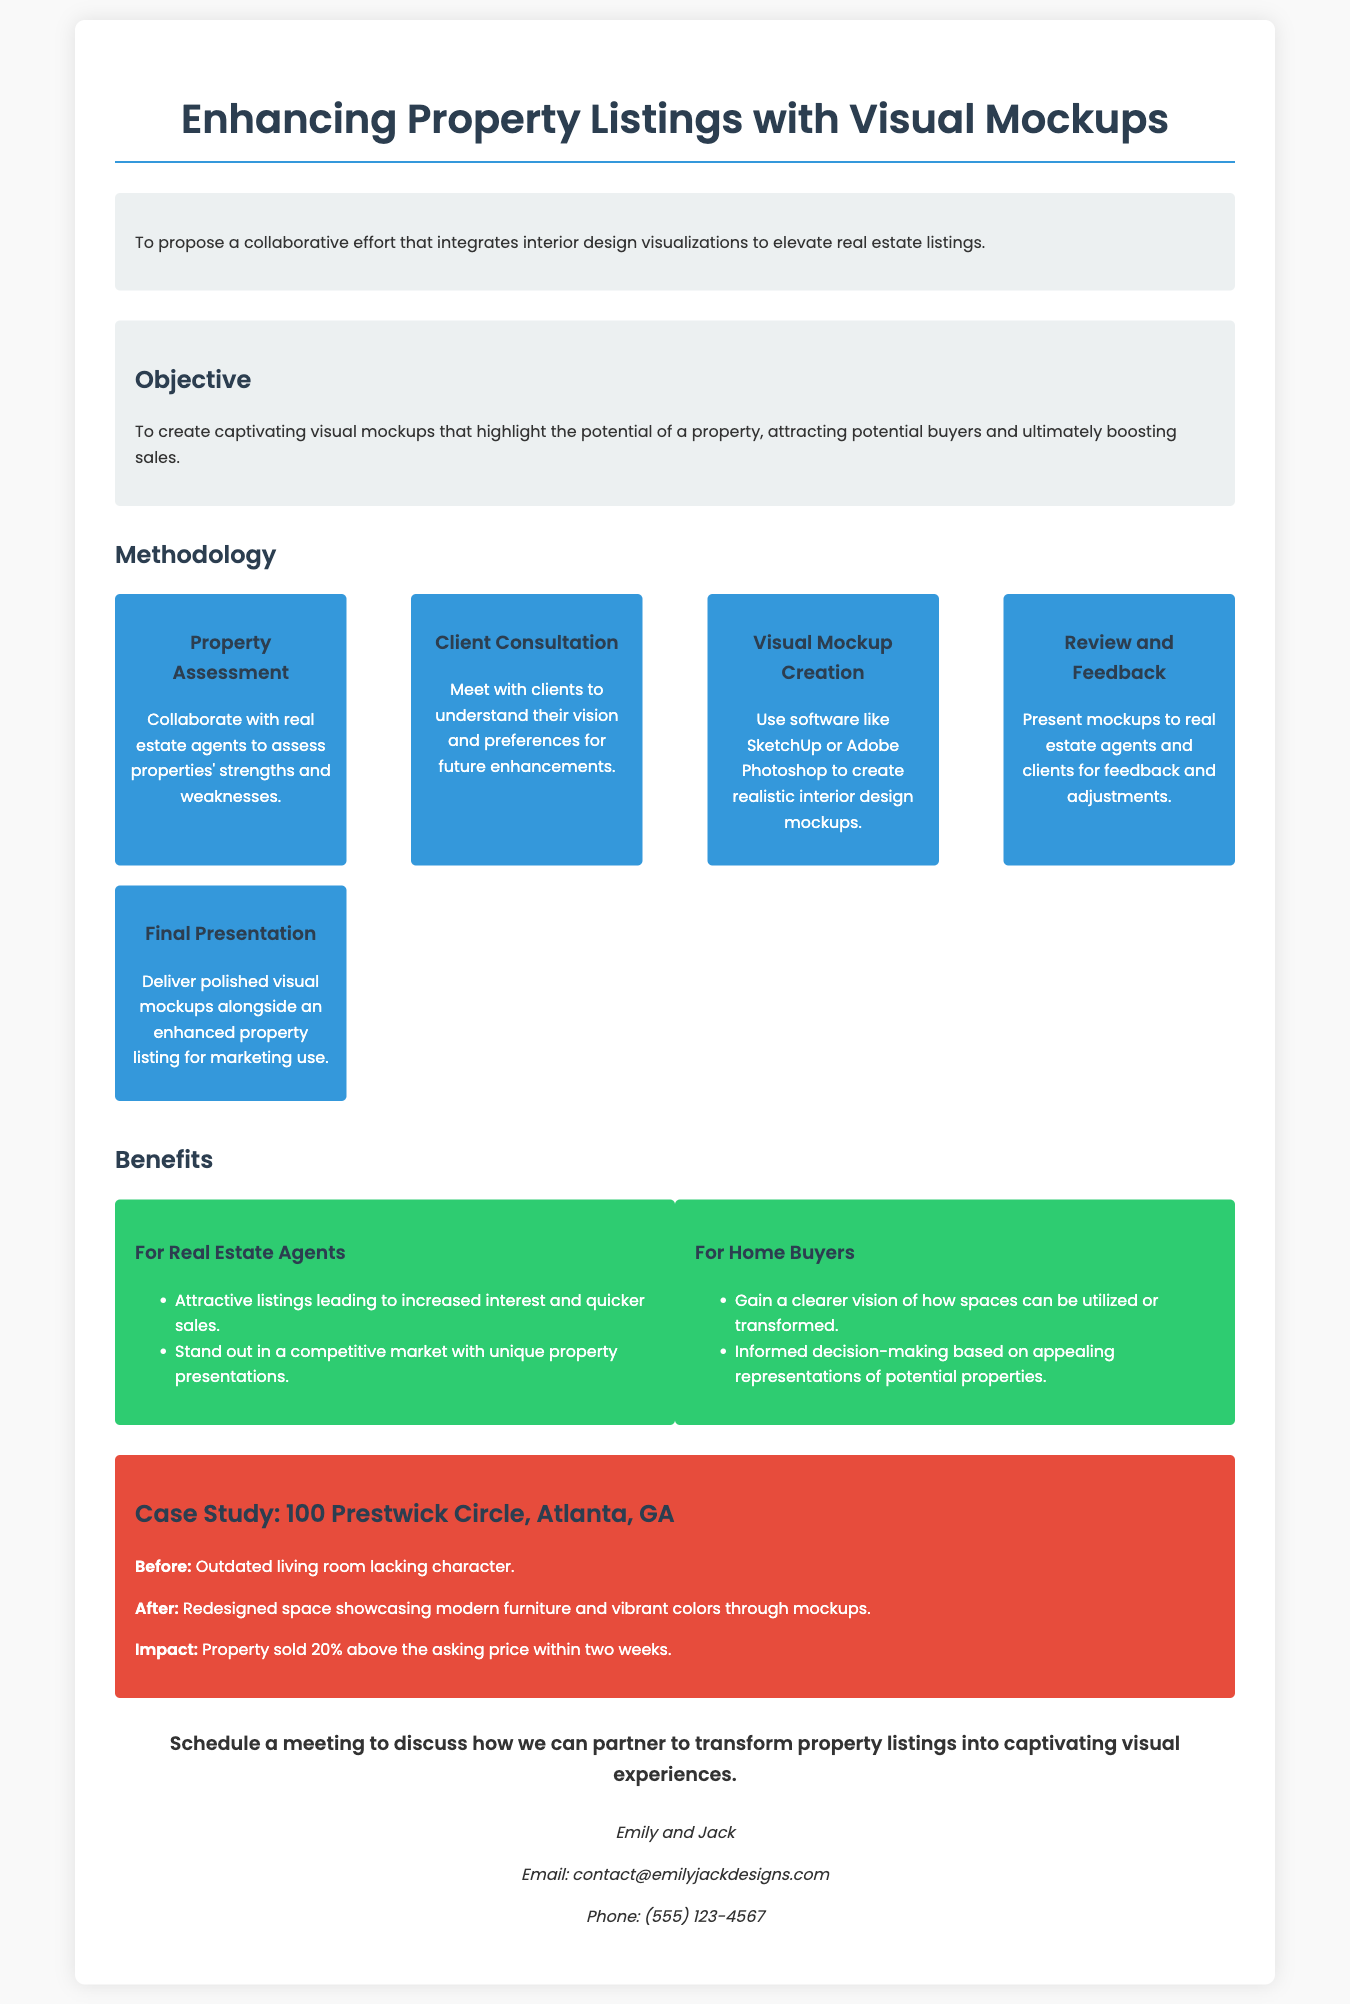What is the title of the proposal? The title of the proposal is stated at the top of the document.
Answer: Enhancing Property Listings with Visual Mockups Who are the authors of the proposal? The authors are mentioned at the bottom of the document, providing their names.
Answer: Emily and Jack What is the objective of the proposal? The objective is detailed in a specific section, summarizing the goal of the proposal.
Answer: To create captivating visual mockups that highlight the potential of a property, attracting potential buyers and ultimately boosting sales What is one software mentioned for creating visual mockups? One specific software is listed under the methodology section as a tool for creating mockups.
Answer: SketchUp What percentage above the asking price was the property sold in the case study? The case study highlights the impact of the redesign on the selling price in terms of percentage.
Answer: 20% How many steps are listed in the methodology section? The steps to be followed in the methodology section are counted for understanding the process.
Answer: Five What is one benefit listed for real estate agents? The benefits for real estate agents are outlined in a separate section, indicating how they can benefit from the proposal.
Answer: Attractive listings leading to increased interest and quicker sales What type of space was mentioned in the case study that was redesigned? The case study describes a specific type of space that underwent a transformation, providing context to the impact.
Answer: Living room 